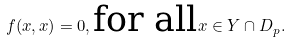Convert formula to latex. <formula><loc_0><loc_0><loc_500><loc_500>f ( x , x ) = 0 , \text {for all} x \in Y \cap D _ { p } .</formula> 